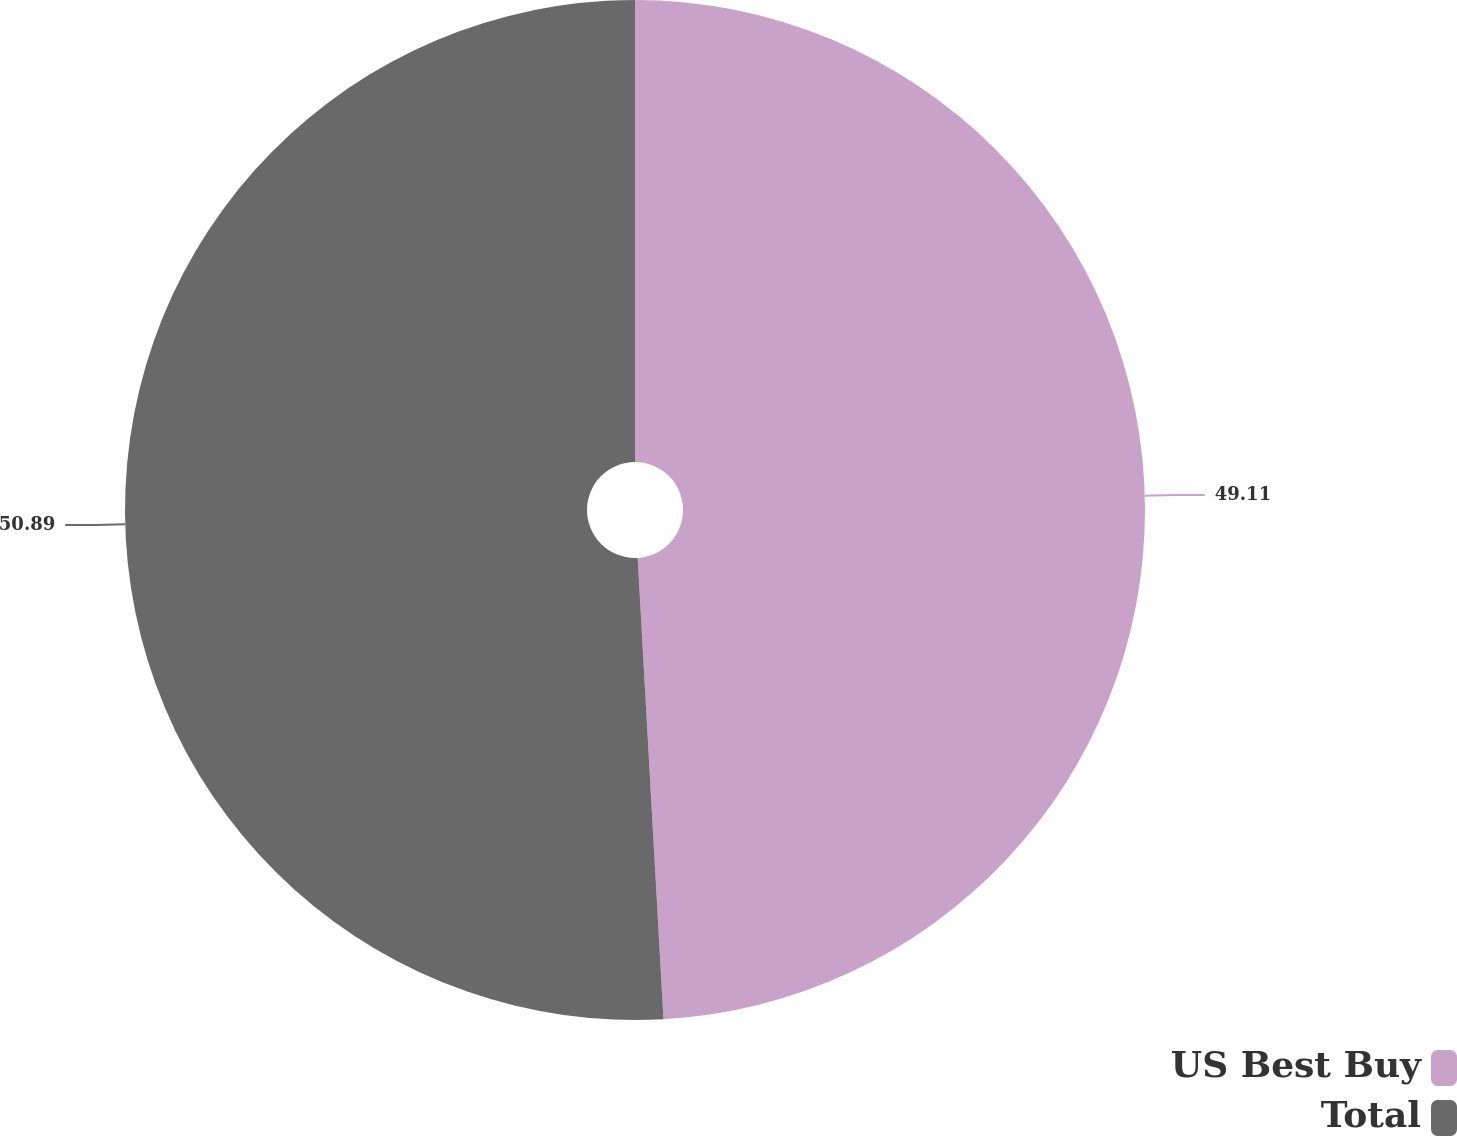Convert chart. <chart><loc_0><loc_0><loc_500><loc_500><pie_chart><fcel>US Best Buy<fcel>Total<nl><fcel>49.11%<fcel>50.89%<nl></chart> 